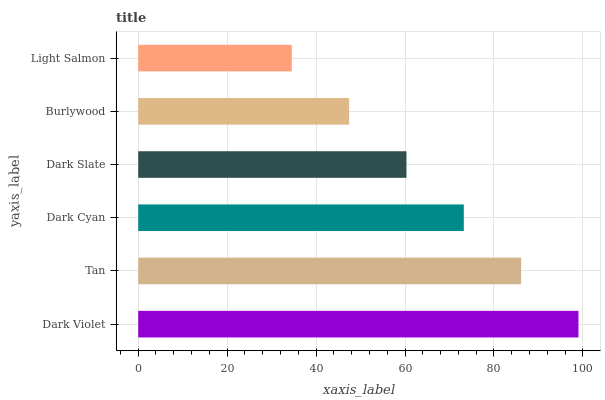Is Light Salmon the minimum?
Answer yes or no. Yes. Is Dark Violet the maximum?
Answer yes or no. Yes. Is Tan the minimum?
Answer yes or no. No. Is Tan the maximum?
Answer yes or no. No. Is Dark Violet greater than Tan?
Answer yes or no. Yes. Is Tan less than Dark Violet?
Answer yes or no. Yes. Is Tan greater than Dark Violet?
Answer yes or no. No. Is Dark Violet less than Tan?
Answer yes or no. No. Is Dark Cyan the high median?
Answer yes or no. Yes. Is Dark Slate the low median?
Answer yes or no. Yes. Is Light Salmon the high median?
Answer yes or no. No. Is Dark Violet the low median?
Answer yes or no. No. 